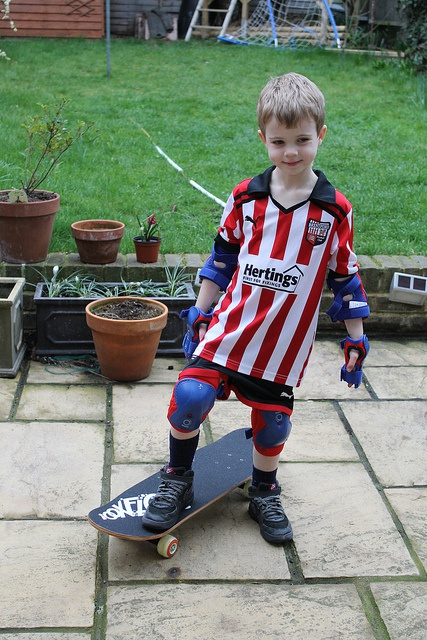Describe the objects in this image and their specific colors. I can see people in brown, black, darkgray, maroon, and lavender tones, potted plant in brown, black, gray, and darkgray tones, potted plant in brown, green, black, maroon, and gray tones, skateboard in brown, gray, black, and white tones, and potted plant in brown, maroon, black, and gray tones in this image. 